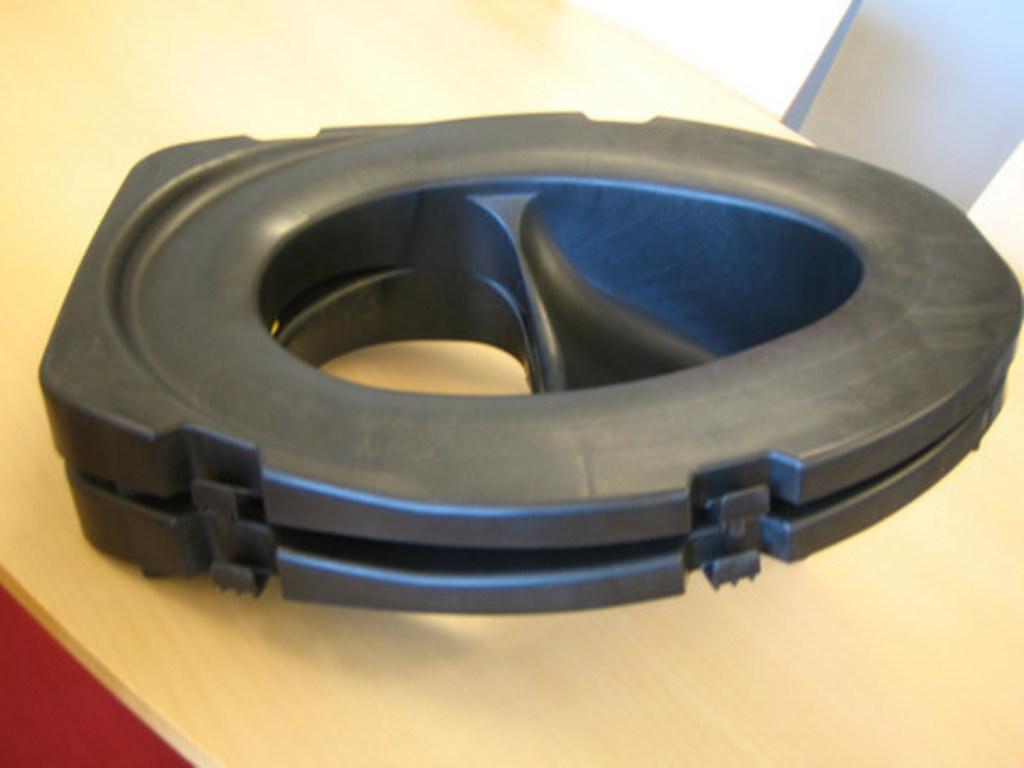Can you describe this image briefly? This picture contains a black color thing which looks like a subwoofer is placed on the table. In the right top of the picture, we see a pillar in white color. 